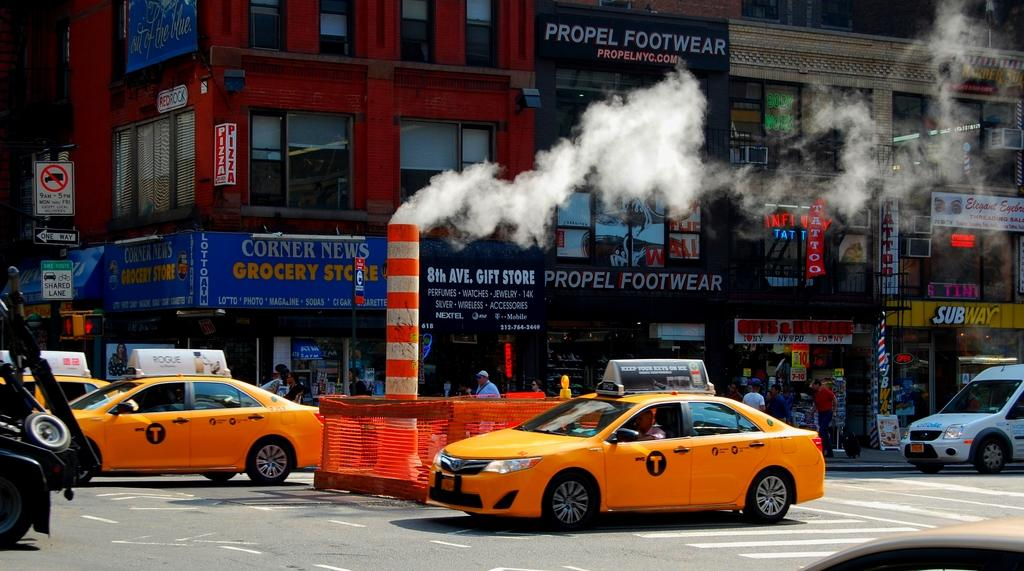<image>
Give a short and clear explanation of the subsequent image. Two taxi cabs driving in front of a store that says Propel Footwear. 